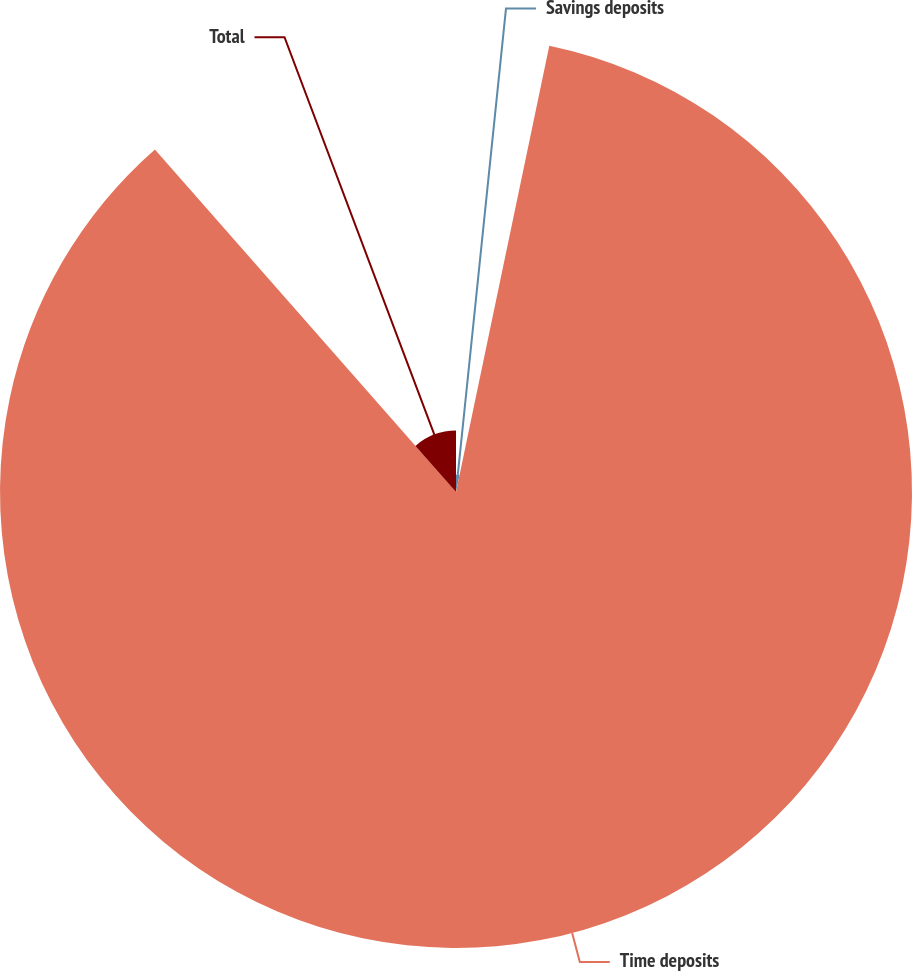Convert chart. <chart><loc_0><loc_0><loc_500><loc_500><pie_chart><fcel>Savings deposits<fcel>Time deposits<fcel>Total<nl><fcel>3.28%<fcel>85.25%<fcel>11.48%<nl></chart> 